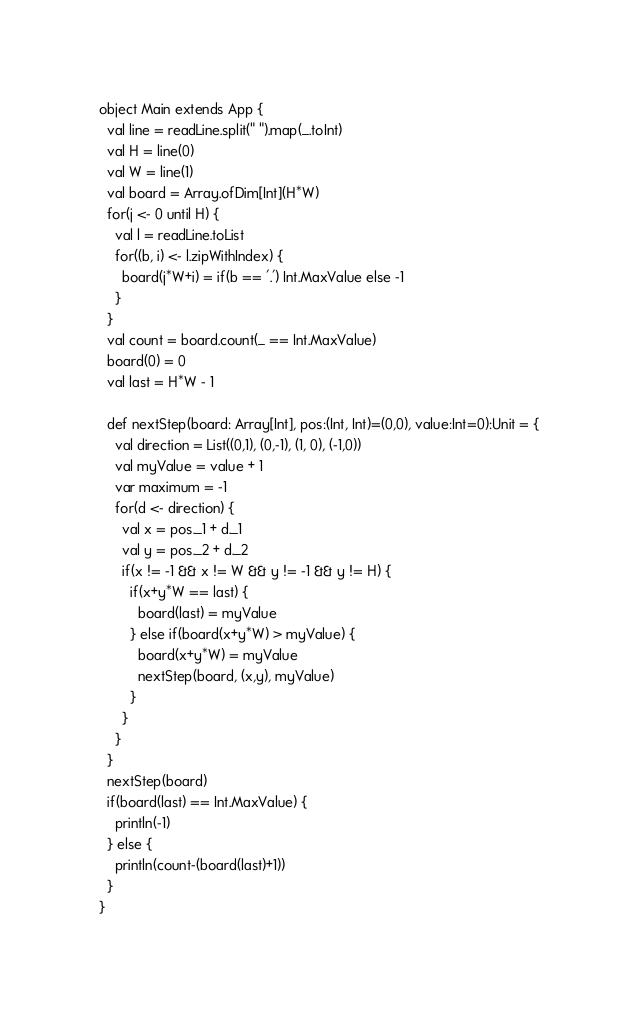<code> <loc_0><loc_0><loc_500><loc_500><_Scala_>object Main extends App {
  val line = readLine.split(" ").map(_.toInt)
  val H = line(0)
  val W = line(1)
  val board = Array.ofDim[Int](H*W)
  for(j <- 0 until H) {
    val l = readLine.toList
    for((b, i) <- l.zipWithIndex) {
      board(j*W+i) = if(b == '.') Int.MaxValue else -1
    }
  }
  val count = board.count(_ == Int.MaxValue)
  board(0) = 0
  val last = H*W - 1

  def nextStep(board: Array[Int], pos:(Int, Int)=(0,0), value:Int=0):Unit = {
    val direction = List((0,1), (0,-1), (1, 0), (-1,0))
    val myValue = value + 1
    var maximum = -1
    for(d <- direction) {
      val x = pos._1 + d._1
      val y = pos._2 + d._2
      if(x != -1 && x != W && y != -1 && y != H) {
        if(x+y*W == last) {
          board(last) = myValue
        } else if(board(x+y*W) > myValue) {
          board(x+y*W) = myValue
          nextStep(board, (x,y), myValue)
        }
      }
    }
  }
  nextStep(board)
  if(board(last) == Int.MaxValue) {
    println(-1)
  } else {
    println(count-(board(last)+1))
  }
}
</code> 